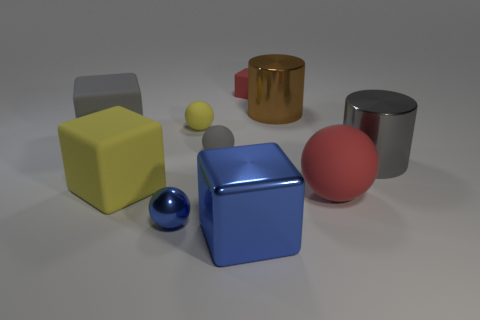There is a sphere that is to the left of the small yellow sphere; does it have the same color as the cube that is in front of the large red ball?
Offer a very short reply. Yes. How many yellow matte blocks are the same size as the gray cylinder?
Offer a very short reply. 1. Is the size of the rubber sphere to the right of the brown metal object the same as the gray cube?
Keep it short and to the point. Yes. The big gray matte thing is what shape?
Ensure brevity in your answer.  Cube. There is a rubber thing that is the same color as the large sphere; what size is it?
Keep it short and to the point. Small. Does the tiny object behind the brown metallic cylinder have the same material as the yellow block?
Your answer should be very brief. Yes. Is there a ball of the same color as the big shiny block?
Your response must be concise. Yes. Does the red thing in front of the small red object have the same shape as the metal thing to the left of the large blue thing?
Provide a short and direct response. Yes. Are there any yellow balls made of the same material as the large blue thing?
Your response must be concise. No. How many cyan things are spheres or small matte spheres?
Your answer should be compact. 0. 